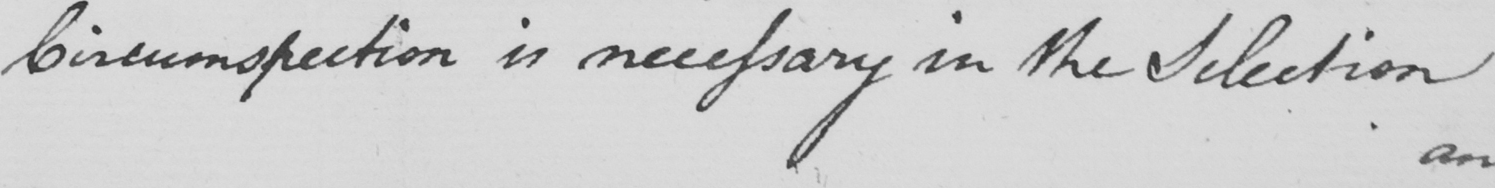Please transcribe the handwritten text in this image. Circumspection is necessary In the Selection 